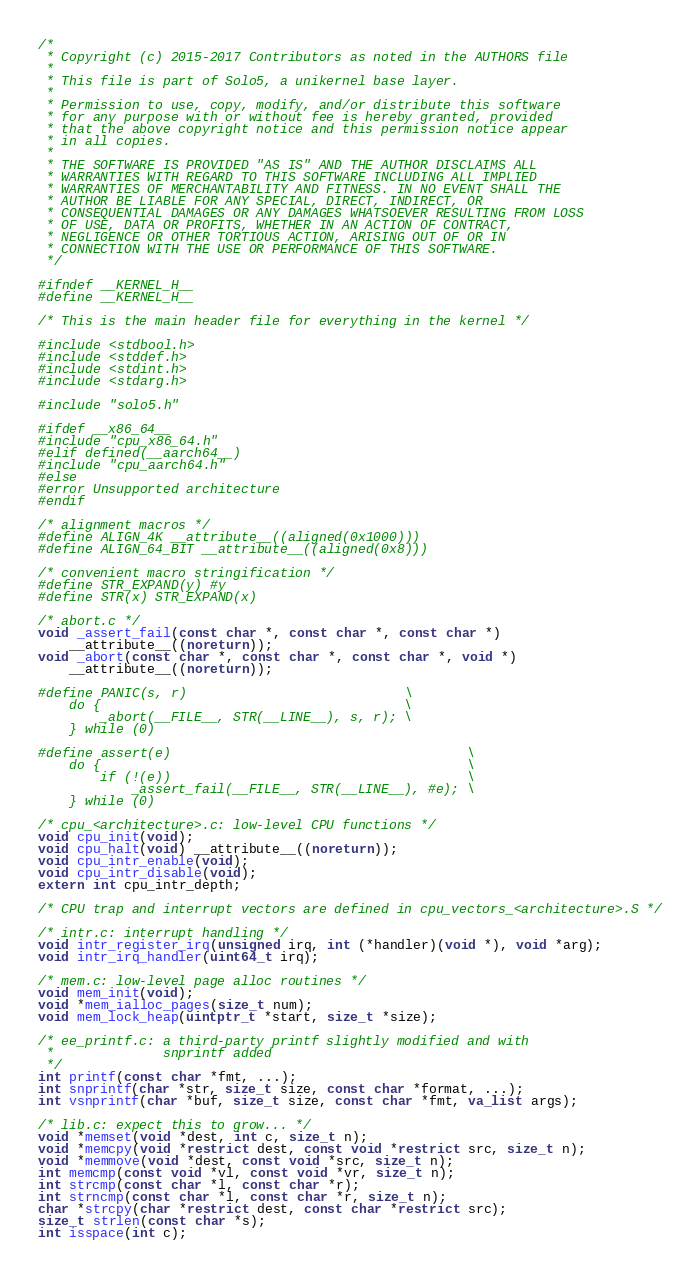<code> <loc_0><loc_0><loc_500><loc_500><_C_>/* 
 * Copyright (c) 2015-2017 Contributors as noted in the AUTHORS file
 *
 * This file is part of Solo5, a unikernel base layer.
 *
 * Permission to use, copy, modify, and/or distribute this software
 * for any purpose with or without fee is hereby granted, provided
 * that the above copyright notice and this permission notice appear
 * in all copies.
 *
 * THE SOFTWARE IS PROVIDED "AS IS" AND THE AUTHOR DISCLAIMS ALL
 * WARRANTIES WITH REGARD TO THIS SOFTWARE INCLUDING ALL IMPLIED
 * WARRANTIES OF MERCHANTABILITY AND FITNESS. IN NO EVENT SHALL THE
 * AUTHOR BE LIABLE FOR ANY SPECIAL, DIRECT, INDIRECT, OR
 * CONSEQUENTIAL DAMAGES OR ANY DAMAGES WHATSOEVER RESULTING FROM LOSS
 * OF USE, DATA OR PROFITS, WHETHER IN AN ACTION OF CONTRACT,
 * NEGLIGENCE OR OTHER TORTIOUS ACTION, ARISING OUT OF OR IN
 * CONNECTION WITH THE USE OR PERFORMANCE OF THIS SOFTWARE.
 */

#ifndef __KERNEL_H__
#define __KERNEL_H__

/* This is the main header file for everything in the kernel */

#include <stdbool.h>
#include <stddef.h>
#include <stdint.h>
#include <stdarg.h>

#include "solo5.h"

#ifdef __x86_64__
#include "cpu_x86_64.h"
#elif defined(__aarch64__)
#include "cpu_aarch64.h"
#else
#error Unsupported architecture
#endif

/* alignment macros */
#define ALIGN_4K __attribute__((aligned(0x1000)))
#define ALIGN_64_BIT __attribute__((aligned(0x8)))

/* convenient macro stringification */
#define STR_EXPAND(y) #y
#define STR(x) STR_EXPAND(x)

/* abort.c */
void _assert_fail(const char *, const char *, const char *)
    __attribute__((noreturn));
void _abort(const char *, const char *, const char *, void *)
    __attribute__((noreturn));

#define PANIC(s, r)                            \
    do {                                       \
        _abort(__FILE__, STR(__LINE__), s, r); \
    } while (0)

#define assert(e)                                      \
    do {                                               \
        if (!(e))                                      \
            _assert_fail(__FILE__, STR(__LINE__), #e); \
    } while (0)

/* cpu_<architecture>.c: low-level CPU functions */
void cpu_init(void);
void cpu_halt(void) __attribute__((noreturn));
void cpu_intr_enable(void);
void cpu_intr_disable(void);
extern int cpu_intr_depth;

/* CPU trap and interrupt vectors are defined in cpu_vectors_<architecture>.S */

/* intr.c: interrupt handling */
void intr_register_irq(unsigned irq, int (*handler)(void *), void *arg);
void intr_irq_handler(uint64_t irq);

/* mem.c: low-level page alloc routines */
void mem_init(void);
void *mem_ialloc_pages(size_t num);
void mem_lock_heap(uintptr_t *start, size_t *size);

/* ee_printf.c: a third-party printf slightly modified and with
 *              snprintf added
 */
int printf(const char *fmt, ...);
int snprintf(char *str, size_t size, const char *format, ...);
int vsnprintf(char *buf, size_t size, const char *fmt, va_list args);

/* lib.c: expect this to grow... */
void *memset(void *dest, int c, size_t n);
void *memcpy(void *restrict dest, const void *restrict src, size_t n);
void *memmove(void *dest, const void *src, size_t n);
int memcmp(const void *vl, const void *vr, size_t n);
int strcmp(const char *l, const char *r);
int strncmp(const char *l, const char *r, size_t n);
char *strcpy(char *restrict dest, const char *restrict src);
size_t strlen(const char *s);
int isspace(int c);
</code> 